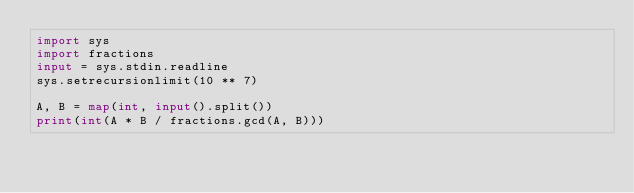Convert code to text. <code><loc_0><loc_0><loc_500><loc_500><_Python_>import sys
import fractions
input = sys.stdin.readline
sys.setrecursionlimit(10 ** 7)

A, B = map(int, input().split())
print(int(A * B / fractions.gcd(A, B)))
</code> 